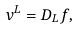<formula> <loc_0><loc_0><loc_500><loc_500>v ^ { L } = D _ { L } f ,</formula> 